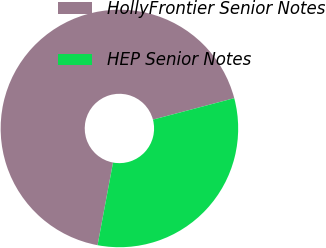Convert chart to OTSL. <chart><loc_0><loc_0><loc_500><loc_500><pie_chart><fcel>HollyFrontier Senior Notes<fcel>HEP Senior Notes<nl><fcel>67.95%<fcel>32.05%<nl></chart> 